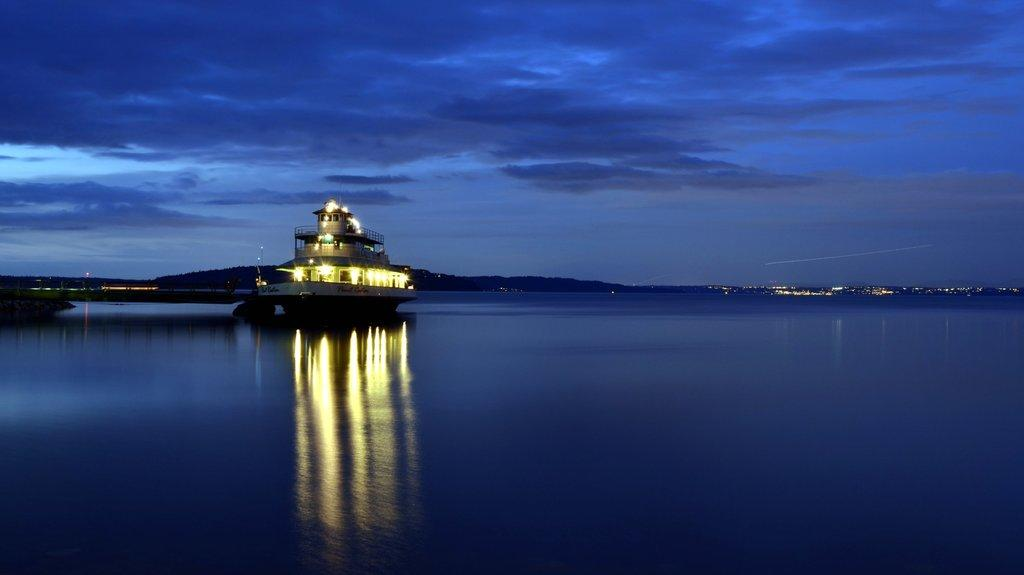What is the main subject of the image? There is a ship in the water. What else can be seen in the image besides the ship? There are buildings visible in the image. Are there any artificial light sources present in the image? Yes, there are lights present in the image. How would you describe the sky in the image? The sky is blue and cloudy. What is the name of the ship's daughter in the image? There is no mention of a ship's daughter in the image, as it only features a ship in the water and other elements. Can you see a cat on the ship in the image? There is no cat visible on the ship in the image. 